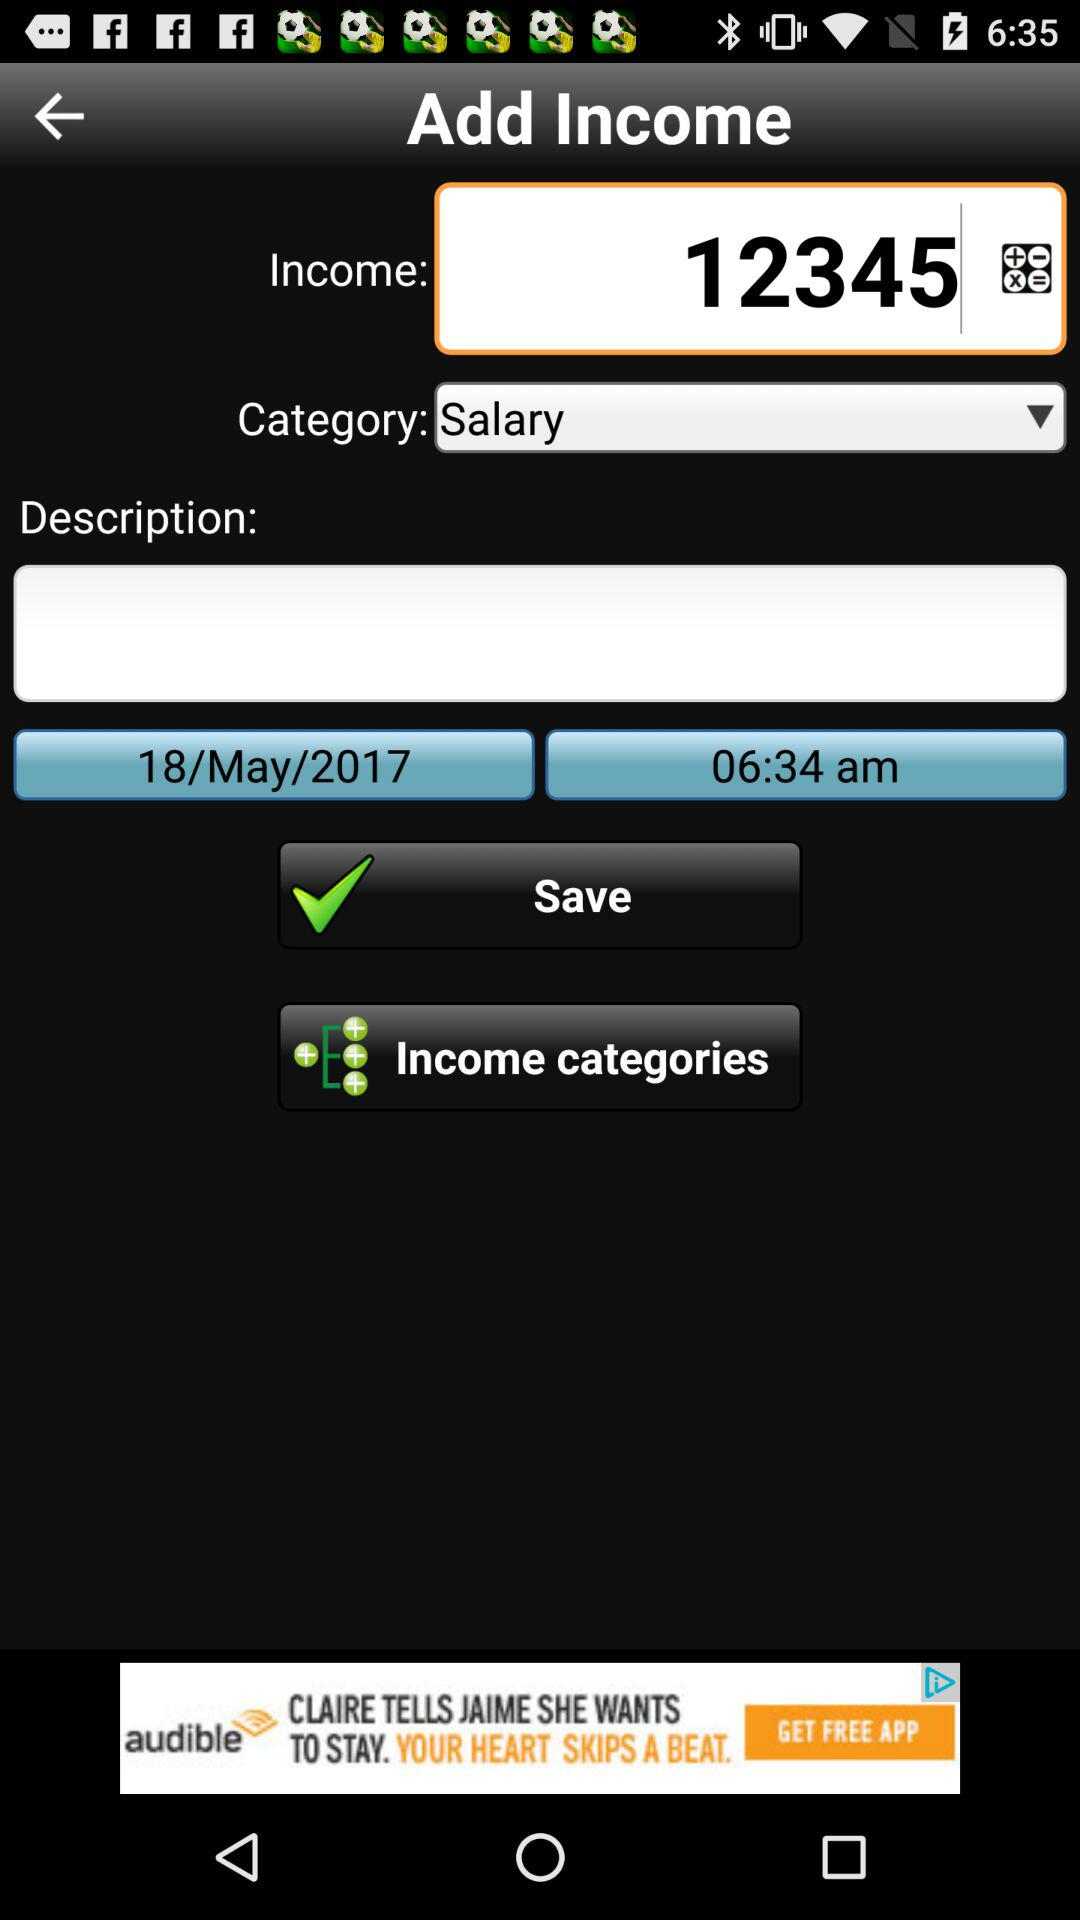What is the time? The time is 06:34 AM. 